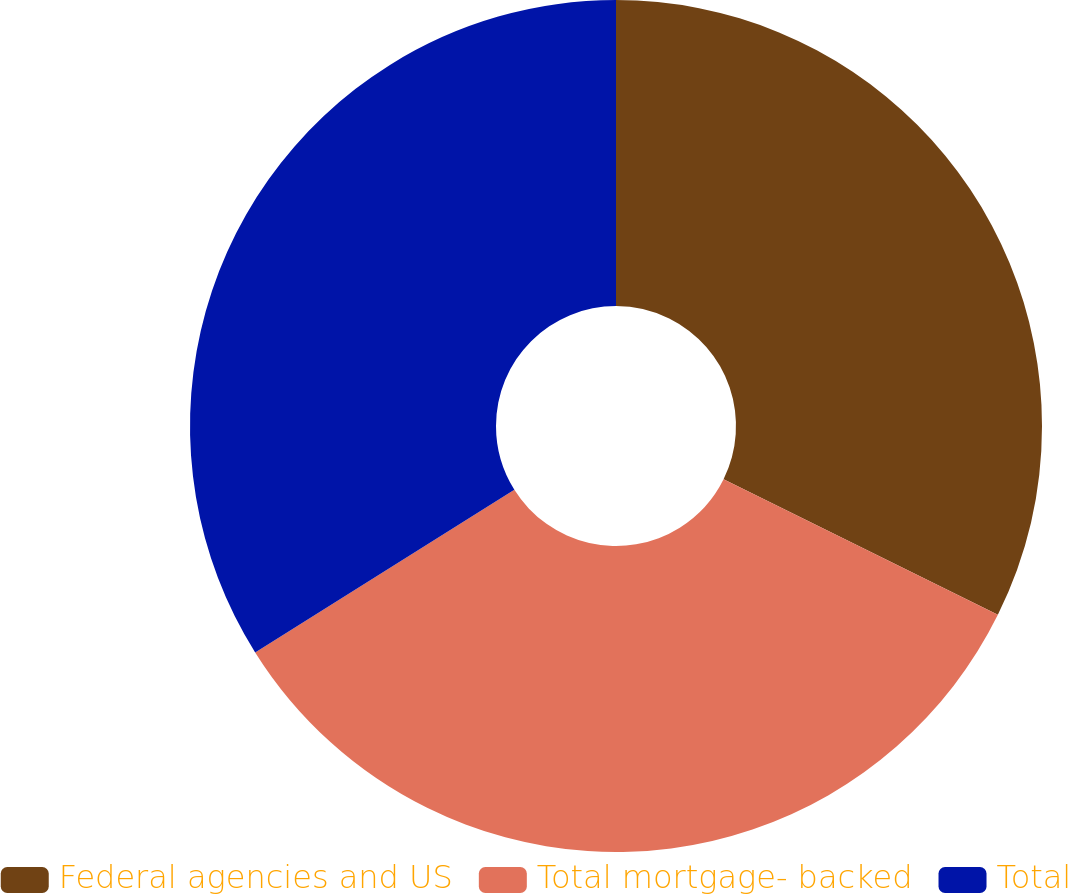Convert chart to OTSL. <chart><loc_0><loc_0><loc_500><loc_500><pie_chart><fcel>Federal agencies and US<fcel>Total mortgage- backed<fcel>Total<nl><fcel>32.31%<fcel>33.77%<fcel>33.92%<nl></chart> 